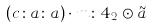Convert formula to latex. <formula><loc_0><loc_0><loc_500><loc_500>( c \colon a \colon a ) \cdot m \colon 4 _ { 2 } \odot \tilde { a }</formula> 